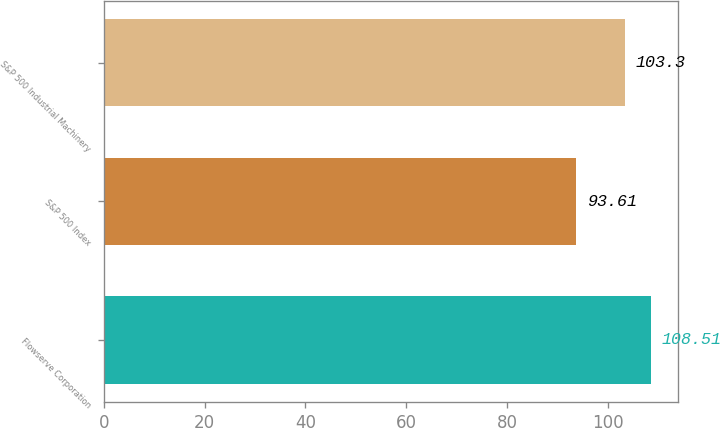<chart> <loc_0><loc_0><loc_500><loc_500><bar_chart><fcel>Flowserve Corporation<fcel>S&P 500 Index<fcel>S&P 500 Industrial Machinery<nl><fcel>108.51<fcel>93.61<fcel>103.3<nl></chart> 